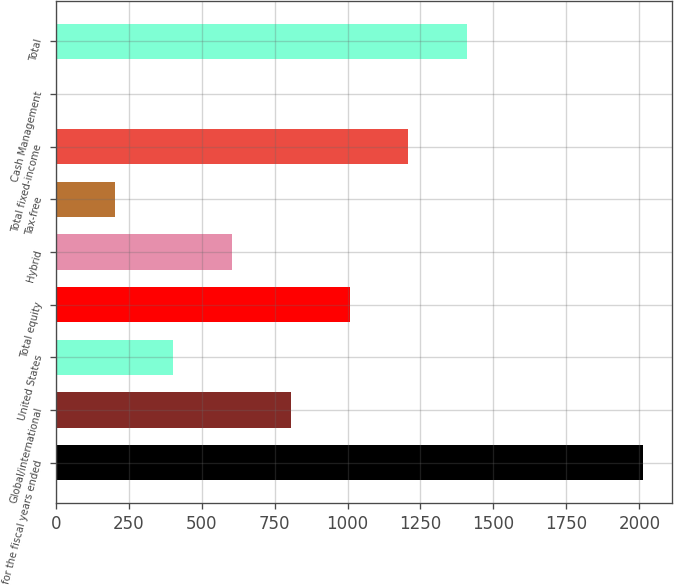Convert chart to OTSL. <chart><loc_0><loc_0><loc_500><loc_500><bar_chart><fcel>for the fiscal years ended<fcel>Global/international<fcel>United States<fcel>Total equity<fcel>Hybrid<fcel>Tax-free<fcel>Total fixed-income<fcel>Cash Management<fcel>Total<nl><fcel>2013<fcel>805.8<fcel>403.4<fcel>1007<fcel>604.6<fcel>202.2<fcel>1208.2<fcel>1<fcel>1409.4<nl></chart> 